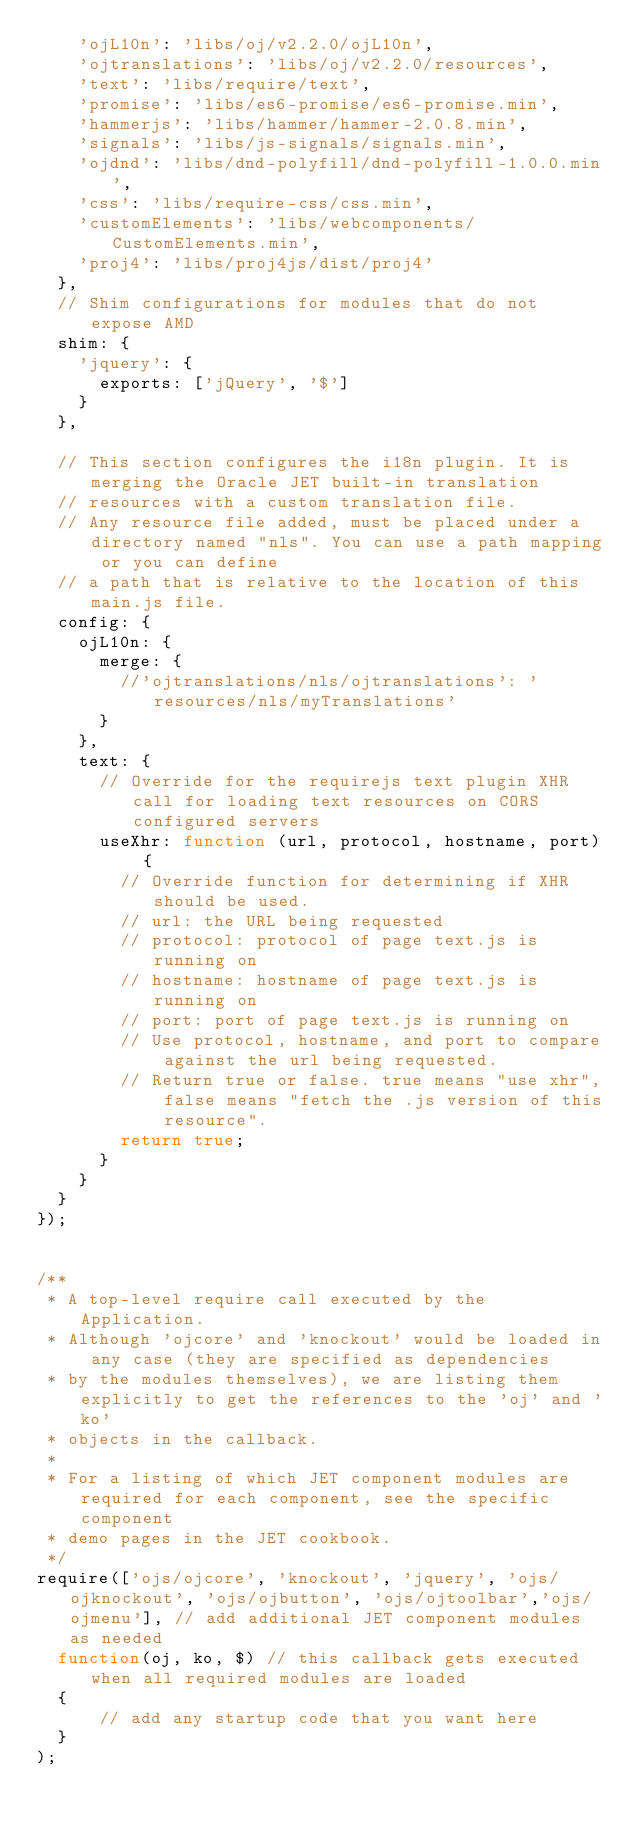Convert code to text. <code><loc_0><loc_0><loc_500><loc_500><_JavaScript_>    'ojL10n': 'libs/oj/v2.2.0/ojL10n',
    'ojtranslations': 'libs/oj/v2.2.0/resources',
    'text': 'libs/require/text',
    'promise': 'libs/es6-promise/es6-promise.min',
    'hammerjs': 'libs/hammer/hammer-2.0.8.min',
    'signals': 'libs/js-signals/signals.min',
    'ojdnd': 'libs/dnd-polyfill/dnd-polyfill-1.0.0.min',
    'css': 'libs/require-css/css.min',
    'customElements': 'libs/webcomponents/CustomElements.min',
    'proj4': 'libs/proj4js/dist/proj4'
  },
  // Shim configurations for modules that do not expose AMD
  shim: {
    'jquery': {
      exports: ['jQuery', '$']
    }
  },

  // This section configures the i18n plugin. It is merging the Oracle JET built-in translation
  // resources with a custom translation file.
  // Any resource file added, must be placed under a directory named "nls". You can use a path mapping or you can define
  // a path that is relative to the location of this main.js file.
  config: {
    ojL10n: {
      merge: {
        //'ojtranslations/nls/ojtranslations': 'resources/nls/myTranslations'
      }
    },
    text: {
      // Override for the requirejs text plugin XHR call for loading text resources on CORS configured servers
      useXhr: function (url, protocol, hostname, port) {
        // Override function for determining if XHR should be used.
        // url: the URL being requested
        // protocol: protocol of page text.js is running on
        // hostname: hostname of page text.js is running on
        // port: port of page text.js is running on
        // Use protocol, hostname, and port to compare against the url being requested.
        // Return true or false. true means "use xhr", false means "fetch the .js version of this resource".
        return true;
      }
    }
  }
});


/**
 * A top-level require call executed by the Application.
 * Although 'ojcore' and 'knockout' would be loaded in any case (they are specified as dependencies
 * by the modules themselves), we are listing them explicitly to get the references to the 'oj' and 'ko'
 * objects in the callback.
 *
 * For a listing of which JET component modules are required for each component, see the specific component
 * demo pages in the JET cookbook.
 */
require(['ojs/ojcore', 'knockout', 'jquery', 'ojs/ojknockout', 'ojs/ojbutton', 'ojs/ojtoolbar','ojs/ojmenu'], // add additional JET component modules as needed
  function(oj, ko, $) // this callback gets executed when all required modules are loaded
  {
      // add any startup code that you want here
  }
);

</code> 